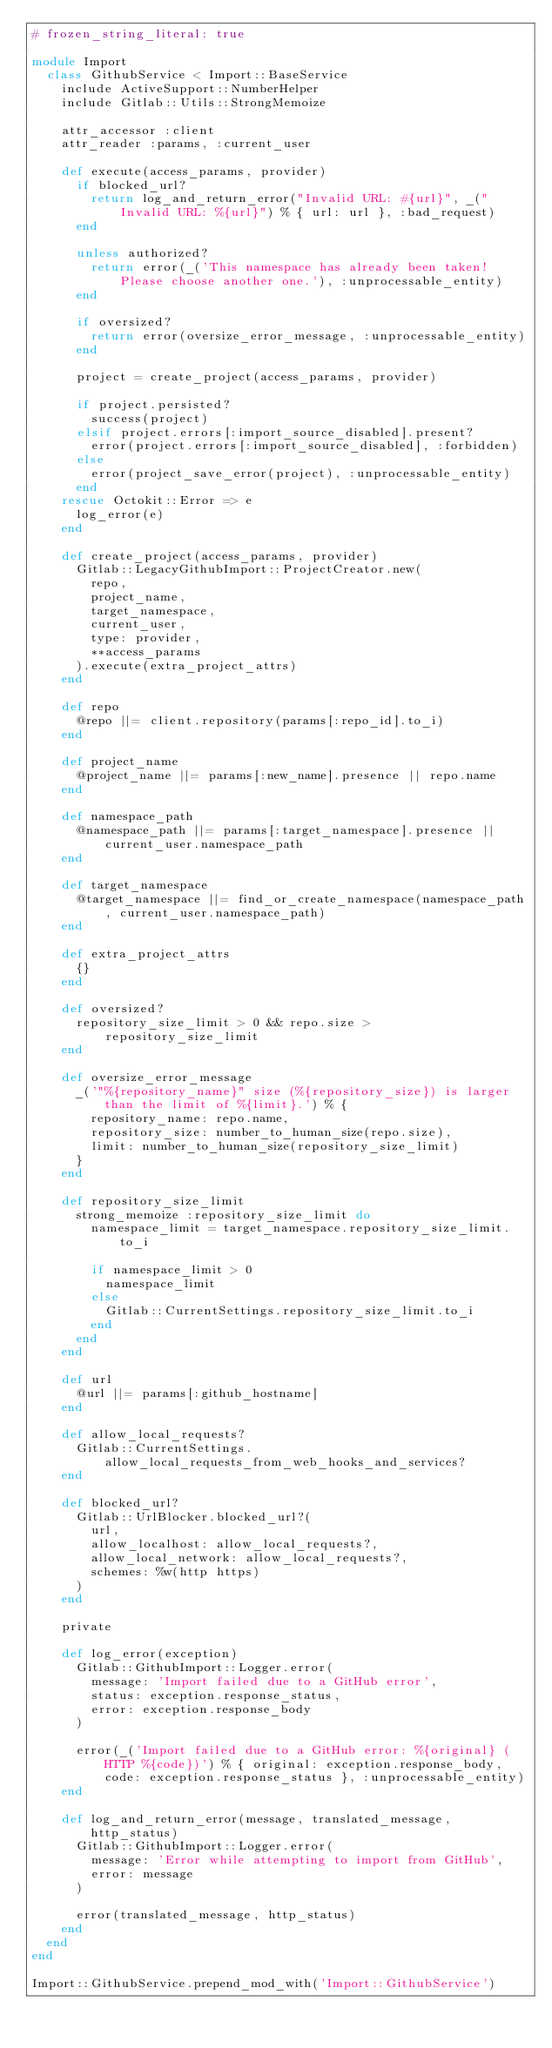<code> <loc_0><loc_0><loc_500><loc_500><_Ruby_># frozen_string_literal: true

module Import
  class GithubService < Import::BaseService
    include ActiveSupport::NumberHelper
    include Gitlab::Utils::StrongMemoize

    attr_accessor :client
    attr_reader :params, :current_user

    def execute(access_params, provider)
      if blocked_url?
        return log_and_return_error("Invalid URL: #{url}", _("Invalid URL: %{url}") % { url: url }, :bad_request)
      end

      unless authorized?
        return error(_('This namespace has already been taken! Please choose another one.'), :unprocessable_entity)
      end

      if oversized?
        return error(oversize_error_message, :unprocessable_entity)
      end

      project = create_project(access_params, provider)

      if project.persisted?
        success(project)
      elsif project.errors[:import_source_disabled].present?
        error(project.errors[:import_source_disabled], :forbidden)
      else
        error(project_save_error(project), :unprocessable_entity)
      end
    rescue Octokit::Error => e
      log_error(e)
    end

    def create_project(access_params, provider)
      Gitlab::LegacyGithubImport::ProjectCreator.new(
        repo,
        project_name,
        target_namespace,
        current_user,
        type: provider,
        **access_params
      ).execute(extra_project_attrs)
    end

    def repo
      @repo ||= client.repository(params[:repo_id].to_i)
    end

    def project_name
      @project_name ||= params[:new_name].presence || repo.name
    end

    def namespace_path
      @namespace_path ||= params[:target_namespace].presence || current_user.namespace_path
    end

    def target_namespace
      @target_namespace ||= find_or_create_namespace(namespace_path, current_user.namespace_path)
    end

    def extra_project_attrs
      {}
    end

    def oversized?
      repository_size_limit > 0 && repo.size > repository_size_limit
    end

    def oversize_error_message
      _('"%{repository_name}" size (%{repository_size}) is larger than the limit of %{limit}.') % {
        repository_name: repo.name,
        repository_size: number_to_human_size(repo.size),
        limit: number_to_human_size(repository_size_limit)
      }
    end

    def repository_size_limit
      strong_memoize :repository_size_limit do
        namespace_limit = target_namespace.repository_size_limit.to_i

        if namespace_limit > 0
          namespace_limit
        else
          Gitlab::CurrentSettings.repository_size_limit.to_i
        end
      end
    end

    def url
      @url ||= params[:github_hostname]
    end

    def allow_local_requests?
      Gitlab::CurrentSettings.allow_local_requests_from_web_hooks_and_services?
    end

    def blocked_url?
      Gitlab::UrlBlocker.blocked_url?(
        url,
        allow_localhost: allow_local_requests?,
        allow_local_network: allow_local_requests?,
        schemes: %w(http https)
      )
    end

    private

    def log_error(exception)
      Gitlab::GithubImport::Logger.error(
        message: 'Import failed due to a GitHub error',
        status: exception.response_status,
        error: exception.response_body
      )

      error(_('Import failed due to a GitHub error: %{original} (HTTP %{code})') % { original: exception.response_body, code: exception.response_status }, :unprocessable_entity)
    end

    def log_and_return_error(message, translated_message, http_status)
      Gitlab::GithubImport::Logger.error(
        message: 'Error while attempting to import from GitHub',
        error: message
      )

      error(translated_message, http_status)
    end
  end
end

Import::GithubService.prepend_mod_with('Import::GithubService')
</code> 